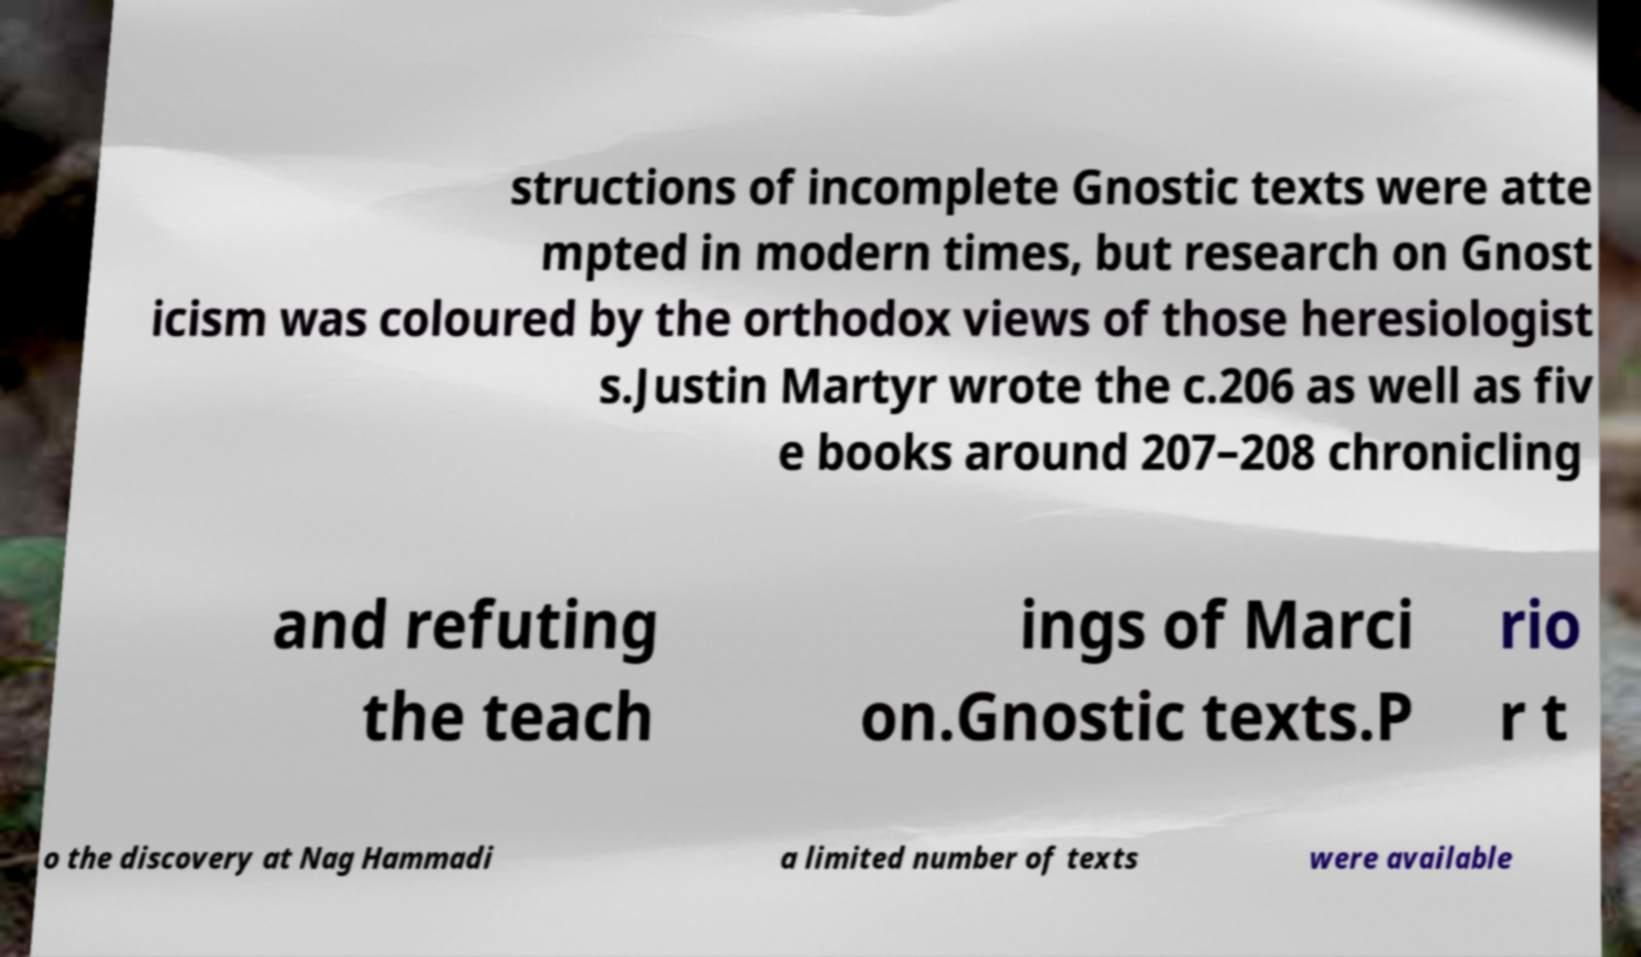Could you extract and type out the text from this image? structions of incomplete Gnostic texts were atte mpted in modern times, but research on Gnost icism was coloured by the orthodox views of those heresiologist s.Justin Martyr wrote the c.206 as well as fiv e books around 207–208 chronicling and refuting the teach ings of Marci on.Gnostic texts.P rio r t o the discovery at Nag Hammadi a limited number of texts were available 